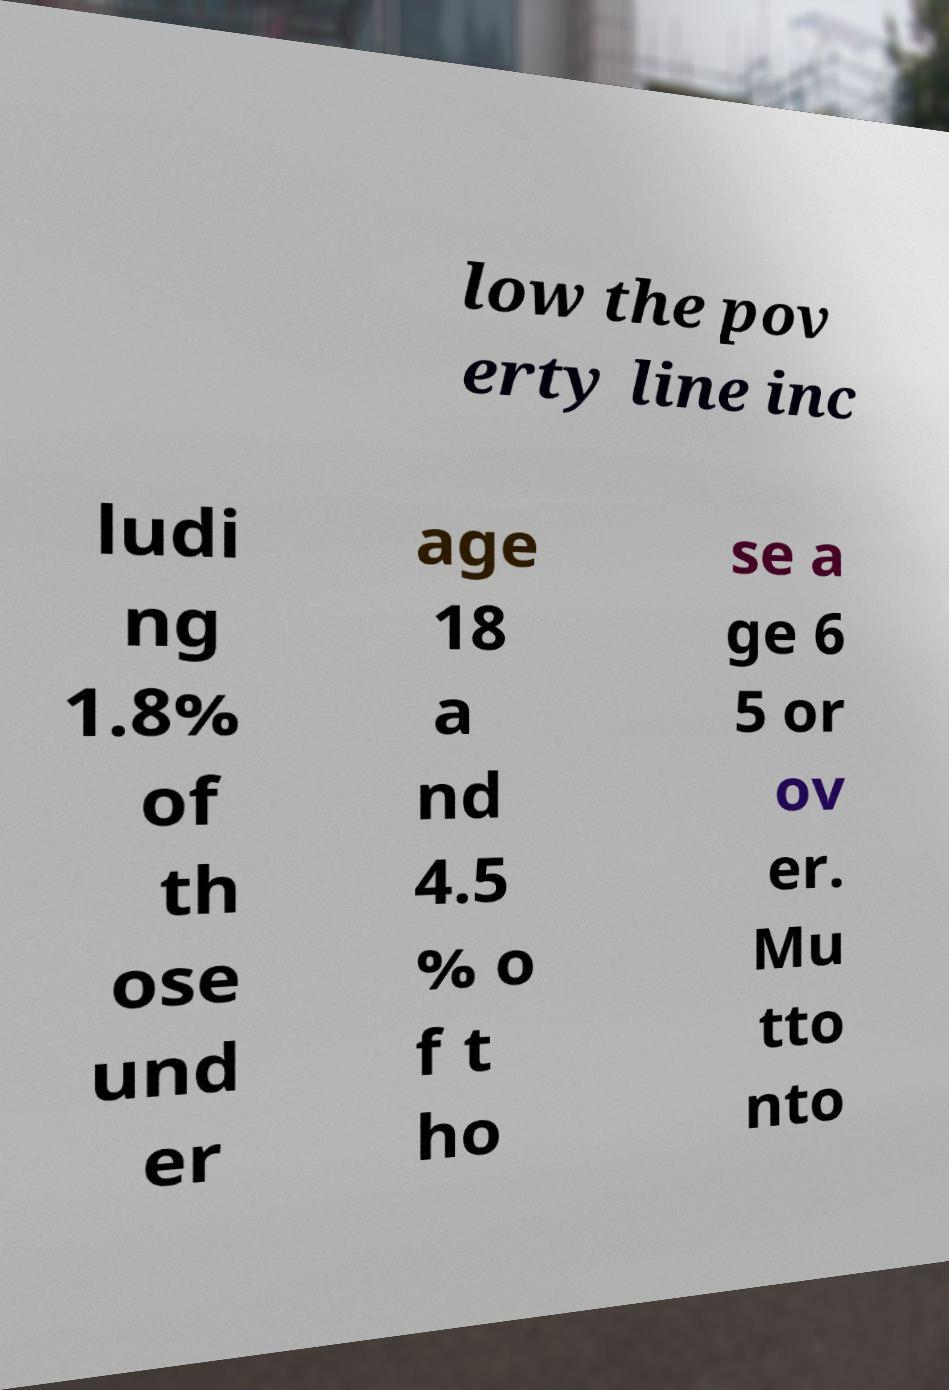What messages or text are displayed in this image? I need them in a readable, typed format. low the pov erty line inc ludi ng 1.8% of th ose und er age 18 a nd 4.5 % o f t ho se a ge 6 5 or ov er. Mu tto nto 